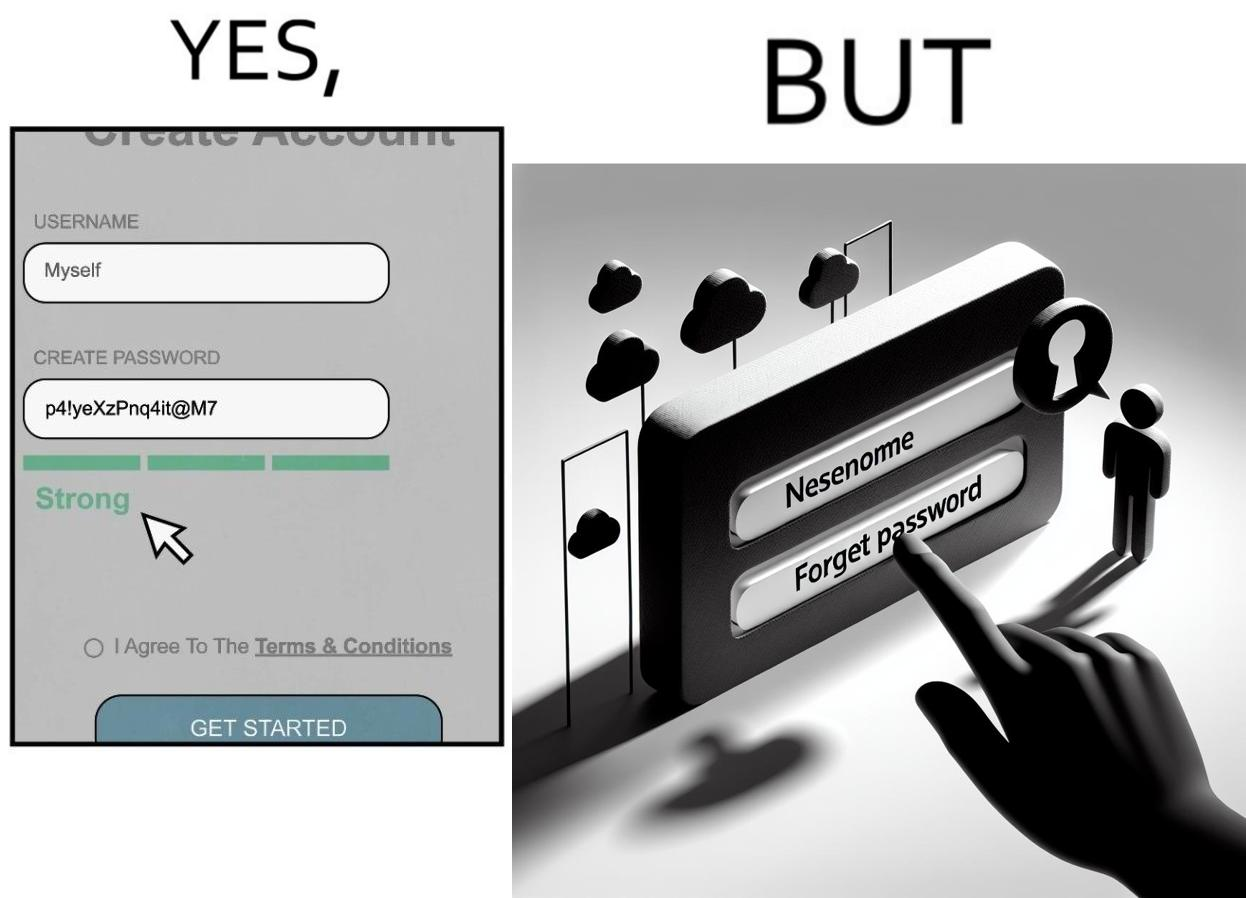What is shown in the left half versus the right half of this image? In the left part of the image: a screenshot of an account creation page of some site with login details filled in such as username and create password and password strength checker showing password as "strong" In the right part of the image: a screenshot of a login page of some site with username filled in and the user about to click on "Forget Password" link as the pointer is over the link 